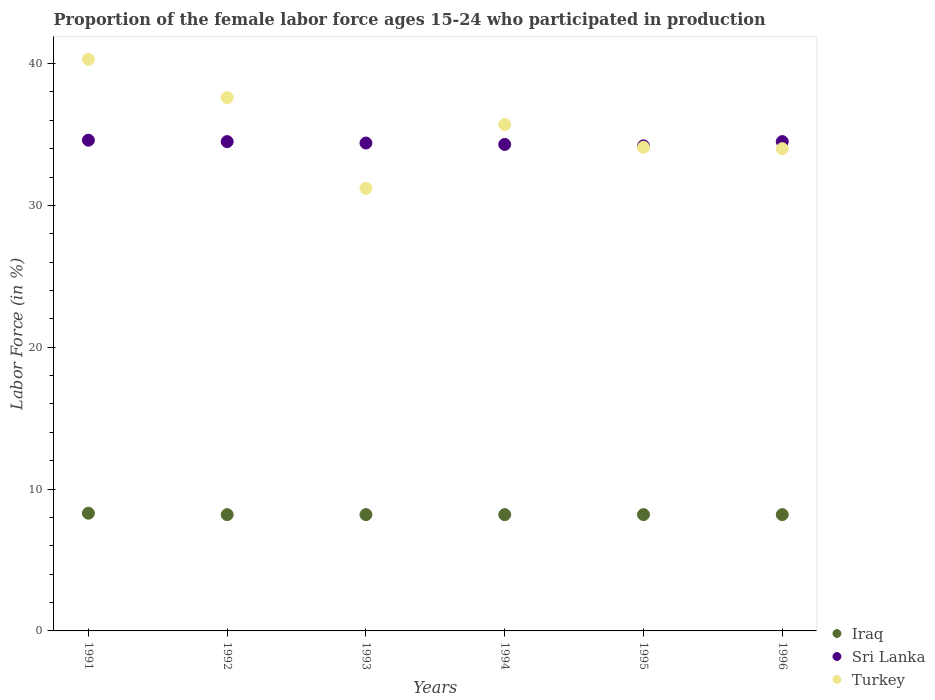How many different coloured dotlines are there?
Your answer should be very brief. 3. Is the number of dotlines equal to the number of legend labels?
Your response must be concise. Yes. What is the proportion of the female labor force who participated in production in Turkey in 1995?
Offer a terse response. 34.1. Across all years, what is the maximum proportion of the female labor force who participated in production in Sri Lanka?
Offer a very short reply. 34.6. Across all years, what is the minimum proportion of the female labor force who participated in production in Iraq?
Keep it short and to the point. 8.2. In which year was the proportion of the female labor force who participated in production in Sri Lanka maximum?
Give a very brief answer. 1991. What is the total proportion of the female labor force who participated in production in Sri Lanka in the graph?
Give a very brief answer. 206.5. What is the difference between the proportion of the female labor force who participated in production in Turkey in 1991 and that in 1995?
Offer a terse response. 6.2. What is the difference between the proportion of the female labor force who participated in production in Turkey in 1993 and the proportion of the female labor force who participated in production in Iraq in 1994?
Provide a short and direct response. 23. What is the average proportion of the female labor force who participated in production in Sri Lanka per year?
Your answer should be very brief. 34.42. In the year 1994, what is the difference between the proportion of the female labor force who participated in production in Turkey and proportion of the female labor force who participated in production in Sri Lanka?
Offer a terse response. 1.4. In how many years, is the proportion of the female labor force who participated in production in Iraq greater than 8 %?
Provide a short and direct response. 6. What is the ratio of the proportion of the female labor force who participated in production in Iraq in 1991 to that in 1994?
Provide a succinct answer. 1.01. What is the difference between the highest and the second highest proportion of the female labor force who participated in production in Turkey?
Your response must be concise. 2.7. What is the difference between the highest and the lowest proportion of the female labor force who participated in production in Sri Lanka?
Your answer should be very brief. 0.4. Is the sum of the proportion of the female labor force who participated in production in Sri Lanka in 1991 and 1996 greater than the maximum proportion of the female labor force who participated in production in Turkey across all years?
Make the answer very short. Yes. What is the title of the graph?
Provide a succinct answer. Proportion of the female labor force ages 15-24 who participated in production. Does "American Samoa" appear as one of the legend labels in the graph?
Offer a very short reply. No. What is the label or title of the X-axis?
Ensure brevity in your answer.  Years. What is the Labor Force (in %) in Iraq in 1991?
Provide a succinct answer. 8.3. What is the Labor Force (in %) of Sri Lanka in 1991?
Offer a terse response. 34.6. What is the Labor Force (in %) of Turkey in 1991?
Make the answer very short. 40.3. What is the Labor Force (in %) of Iraq in 1992?
Ensure brevity in your answer.  8.2. What is the Labor Force (in %) of Sri Lanka in 1992?
Offer a terse response. 34.5. What is the Labor Force (in %) in Turkey in 1992?
Your response must be concise. 37.6. What is the Labor Force (in %) of Iraq in 1993?
Provide a succinct answer. 8.2. What is the Labor Force (in %) of Sri Lanka in 1993?
Make the answer very short. 34.4. What is the Labor Force (in %) in Turkey in 1993?
Your response must be concise. 31.2. What is the Labor Force (in %) of Iraq in 1994?
Offer a terse response. 8.2. What is the Labor Force (in %) of Sri Lanka in 1994?
Your answer should be compact. 34.3. What is the Labor Force (in %) of Turkey in 1994?
Ensure brevity in your answer.  35.7. What is the Labor Force (in %) in Iraq in 1995?
Provide a succinct answer. 8.2. What is the Labor Force (in %) of Sri Lanka in 1995?
Ensure brevity in your answer.  34.2. What is the Labor Force (in %) of Turkey in 1995?
Provide a short and direct response. 34.1. What is the Labor Force (in %) of Iraq in 1996?
Give a very brief answer. 8.2. What is the Labor Force (in %) in Sri Lanka in 1996?
Offer a very short reply. 34.5. What is the Labor Force (in %) in Turkey in 1996?
Provide a succinct answer. 34. Across all years, what is the maximum Labor Force (in %) in Iraq?
Provide a short and direct response. 8.3. Across all years, what is the maximum Labor Force (in %) in Sri Lanka?
Your answer should be very brief. 34.6. Across all years, what is the maximum Labor Force (in %) of Turkey?
Your answer should be compact. 40.3. Across all years, what is the minimum Labor Force (in %) of Iraq?
Ensure brevity in your answer.  8.2. Across all years, what is the minimum Labor Force (in %) of Sri Lanka?
Provide a short and direct response. 34.2. Across all years, what is the minimum Labor Force (in %) of Turkey?
Your answer should be compact. 31.2. What is the total Labor Force (in %) in Iraq in the graph?
Ensure brevity in your answer.  49.3. What is the total Labor Force (in %) in Sri Lanka in the graph?
Make the answer very short. 206.5. What is the total Labor Force (in %) in Turkey in the graph?
Make the answer very short. 212.9. What is the difference between the Labor Force (in %) in Sri Lanka in 1991 and that in 1992?
Your answer should be compact. 0.1. What is the difference between the Labor Force (in %) of Turkey in 1991 and that in 1992?
Give a very brief answer. 2.7. What is the difference between the Labor Force (in %) of Iraq in 1991 and that in 1993?
Offer a terse response. 0.1. What is the difference between the Labor Force (in %) of Sri Lanka in 1991 and that in 1993?
Your answer should be compact. 0.2. What is the difference between the Labor Force (in %) in Turkey in 1991 and that in 1993?
Offer a terse response. 9.1. What is the difference between the Labor Force (in %) in Sri Lanka in 1991 and that in 1994?
Your response must be concise. 0.3. What is the difference between the Labor Force (in %) of Iraq in 1991 and that in 1995?
Your response must be concise. 0.1. What is the difference between the Labor Force (in %) in Turkey in 1991 and that in 1995?
Offer a very short reply. 6.2. What is the difference between the Labor Force (in %) in Sri Lanka in 1991 and that in 1996?
Offer a very short reply. 0.1. What is the difference between the Labor Force (in %) of Turkey in 1991 and that in 1996?
Your response must be concise. 6.3. What is the difference between the Labor Force (in %) of Sri Lanka in 1992 and that in 1993?
Your response must be concise. 0.1. What is the difference between the Labor Force (in %) of Turkey in 1992 and that in 1993?
Offer a terse response. 6.4. What is the difference between the Labor Force (in %) of Iraq in 1992 and that in 1996?
Your answer should be compact. 0. What is the difference between the Labor Force (in %) in Sri Lanka in 1992 and that in 1996?
Offer a very short reply. 0. What is the difference between the Labor Force (in %) of Turkey in 1992 and that in 1996?
Your answer should be very brief. 3.6. What is the difference between the Labor Force (in %) of Sri Lanka in 1993 and that in 1995?
Provide a succinct answer. 0.2. What is the difference between the Labor Force (in %) of Turkey in 1993 and that in 1995?
Provide a short and direct response. -2.9. What is the difference between the Labor Force (in %) in Sri Lanka in 1993 and that in 1996?
Provide a succinct answer. -0.1. What is the difference between the Labor Force (in %) in Iraq in 1994 and that in 1996?
Ensure brevity in your answer.  0. What is the difference between the Labor Force (in %) of Sri Lanka in 1994 and that in 1996?
Keep it short and to the point. -0.2. What is the difference between the Labor Force (in %) of Iraq in 1995 and that in 1996?
Provide a short and direct response. 0. What is the difference between the Labor Force (in %) of Turkey in 1995 and that in 1996?
Ensure brevity in your answer.  0.1. What is the difference between the Labor Force (in %) of Iraq in 1991 and the Labor Force (in %) of Sri Lanka in 1992?
Make the answer very short. -26.2. What is the difference between the Labor Force (in %) in Iraq in 1991 and the Labor Force (in %) in Turkey in 1992?
Provide a short and direct response. -29.3. What is the difference between the Labor Force (in %) in Iraq in 1991 and the Labor Force (in %) in Sri Lanka in 1993?
Ensure brevity in your answer.  -26.1. What is the difference between the Labor Force (in %) in Iraq in 1991 and the Labor Force (in %) in Turkey in 1993?
Your answer should be very brief. -22.9. What is the difference between the Labor Force (in %) in Sri Lanka in 1991 and the Labor Force (in %) in Turkey in 1993?
Your response must be concise. 3.4. What is the difference between the Labor Force (in %) in Iraq in 1991 and the Labor Force (in %) in Turkey in 1994?
Offer a very short reply. -27.4. What is the difference between the Labor Force (in %) of Sri Lanka in 1991 and the Labor Force (in %) of Turkey in 1994?
Provide a short and direct response. -1.1. What is the difference between the Labor Force (in %) in Iraq in 1991 and the Labor Force (in %) in Sri Lanka in 1995?
Keep it short and to the point. -25.9. What is the difference between the Labor Force (in %) of Iraq in 1991 and the Labor Force (in %) of Turkey in 1995?
Ensure brevity in your answer.  -25.8. What is the difference between the Labor Force (in %) in Sri Lanka in 1991 and the Labor Force (in %) in Turkey in 1995?
Provide a short and direct response. 0.5. What is the difference between the Labor Force (in %) in Iraq in 1991 and the Labor Force (in %) in Sri Lanka in 1996?
Your answer should be very brief. -26.2. What is the difference between the Labor Force (in %) in Iraq in 1991 and the Labor Force (in %) in Turkey in 1996?
Your answer should be very brief. -25.7. What is the difference between the Labor Force (in %) in Sri Lanka in 1991 and the Labor Force (in %) in Turkey in 1996?
Your response must be concise. 0.6. What is the difference between the Labor Force (in %) of Iraq in 1992 and the Labor Force (in %) of Sri Lanka in 1993?
Provide a succinct answer. -26.2. What is the difference between the Labor Force (in %) of Iraq in 1992 and the Labor Force (in %) of Sri Lanka in 1994?
Offer a terse response. -26.1. What is the difference between the Labor Force (in %) of Iraq in 1992 and the Labor Force (in %) of Turkey in 1994?
Keep it short and to the point. -27.5. What is the difference between the Labor Force (in %) in Sri Lanka in 1992 and the Labor Force (in %) in Turkey in 1994?
Offer a terse response. -1.2. What is the difference between the Labor Force (in %) in Iraq in 1992 and the Labor Force (in %) in Turkey in 1995?
Offer a very short reply. -25.9. What is the difference between the Labor Force (in %) in Iraq in 1992 and the Labor Force (in %) in Sri Lanka in 1996?
Ensure brevity in your answer.  -26.3. What is the difference between the Labor Force (in %) in Iraq in 1992 and the Labor Force (in %) in Turkey in 1996?
Provide a short and direct response. -25.8. What is the difference between the Labor Force (in %) in Sri Lanka in 1992 and the Labor Force (in %) in Turkey in 1996?
Your answer should be very brief. 0.5. What is the difference between the Labor Force (in %) in Iraq in 1993 and the Labor Force (in %) in Sri Lanka in 1994?
Ensure brevity in your answer.  -26.1. What is the difference between the Labor Force (in %) in Iraq in 1993 and the Labor Force (in %) in Turkey in 1994?
Ensure brevity in your answer.  -27.5. What is the difference between the Labor Force (in %) of Iraq in 1993 and the Labor Force (in %) of Turkey in 1995?
Your answer should be compact. -25.9. What is the difference between the Labor Force (in %) of Iraq in 1993 and the Labor Force (in %) of Sri Lanka in 1996?
Ensure brevity in your answer.  -26.3. What is the difference between the Labor Force (in %) in Iraq in 1993 and the Labor Force (in %) in Turkey in 1996?
Your response must be concise. -25.8. What is the difference between the Labor Force (in %) of Iraq in 1994 and the Labor Force (in %) of Sri Lanka in 1995?
Your answer should be compact. -26. What is the difference between the Labor Force (in %) in Iraq in 1994 and the Labor Force (in %) in Turkey in 1995?
Ensure brevity in your answer.  -25.9. What is the difference between the Labor Force (in %) of Iraq in 1994 and the Labor Force (in %) of Sri Lanka in 1996?
Keep it short and to the point. -26.3. What is the difference between the Labor Force (in %) of Iraq in 1994 and the Labor Force (in %) of Turkey in 1996?
Give a very brief answer. -25.8. What is the difference between the Labor Force (in %) of Iraq in 1995 and the Labor Force (in %) of Sri Lanka in 1996?
Your response must be concise. -26.3. What is the difference between the Labor Force (in %) in Iraq in 1995 and the Labor Force (in %) in Turkey in 1996?
Offer a very short reply. -25.8. What is the average Labor Force (in %) in Iraq per year?
Make the answer very short. 8.22. What is the average Labor Force (in %) in Sri Lanka per year?
Provide a succinct answer. 34.42. What is the average Labor Force (in %) in Turkey per year?
Your response must be concise. 35.48. In the year 1991, what is the difference between the Labor Force (in %) in Iraq and Labor Force (in %) in Sri Lanka?
Make the answer very short. -26.3. In the year 1991, what is the difference between the Labor Force (in %) of Iraq and Labor Force (in %) of Turkey?
Your answer should be very brief. -32. In the year 1991, what is the difference between the Labor Force (in %) in Sri Lanka and Labor Force (in %) in Turkey?
Provide a succinct answer. -5.7. In the year 1992, what is the difference between the Labor Force (in %) in Iraq and Labor Force (in %) in Sri Lanka?
Offer a very short reply. -26.3. In the year 1992, what is the difference between the Labor Force (in %) of Iraq and Labor Force (in %) of Turkey?
Provide a succinct answer. -29.4. In the year 1993, what is the difference between the Labor Force (in %) of Iraq and Labor Force (in %) of Sri Lanka?
Your response must be concise. -26.2. In the year 1993, what is the difference between the Labor Force (in %) of Iraq and Labor Force (in %) of Turkey?
Your response must be concise. -23. In the year 1993, what is the difference between the Labor Force (in %) of Sri Lanka and Labor Force (in %) of Turkey?
Keep it short and to the point. 3.2. In the year 1994, what is the difference between the Labor Force (in %) of Iraq and Labor Force (in %) of Sri Lanka?
Offer a terse response. -26.1. In the year 1994, what is the difference between the Labor Force (in %) in Iraq and Labor Force (in %) in Turkey?
Make the answer very short. -27.5. In the year 1995, what is the difference between the Labor Force (in %) in Iraq and Labor Force (in %) in Sri Lanka?
Provide a short and direct response. -26. In the year 1995, what is the difference between the Labor Force (in %) of Iraq and Labor Force (in %) of Turkey?
Give a very brief answer. -25.9. In the year 1995, what is the difference between the Labor Force (in %) in Sri Lanka and Labor Force (in %) in Turkey?
Give a very brief answer. 0.1. In the year 1996, what is the difference between the Labor Force (in %) of Iraq and Labor Force (in %) of Sri Lanka?
Your answer should be compact. -26.3. In the year 1996, what is the difference between the Labor Force (in %) in Iraq and Labor Force (in %) in Turkey?
Make the answer very short. -25.8. In the year 1996, what is the difference between the Labor Force (in %) in Sri Lanka and Labor Force (in %) in Turkey?
Your response must be concise. 0.5. What is the ratio of the Labor Force (in %) in Iraq in 1991 to that in 1992?
Your answer should be compact. 1.01. What is the ratio of the Labor Force (in %) of Sri Lanka in 1991 to that in 1992?
Your answer should be compact. 1. What is the ratio of the Labor Force (in %) in Turkey in 1991 to that in 1992?
Offer a terse response. 1.07. What is the ratio of the Labor Force (in %) of Iraq in 1991 to that in 1993?
Keep it short and to the point. 1.01. What is the ratio of the Labor Force (in %) of Sri Lanka in 1991 to that in 1993?
Make the answer very short. 1.01. What is the ratio of the Labor Force (in %) of Turkey in 1991 to that in 1993?
Give a very brief answer. 1.29. What is the ratio of the Labor Force (in %) of Iraq in 1991 to that in 1994?
Offer a terse response. 1.01. What is the ratio of the Labor Force (in %) in Sri Lanka in 1991 to that in 1994?
Provide a succinct answer. 1.01. What is the ratio of the Labor Force (in %) of Turkey in 1991 to that in 1994?
Ensure brevity in your answer.  1.13. What is the ratio of the Labor Force (in %) of Iraq in 1991 to that in 1995?
Offer a terse response. 1.01. What is the ratio of the Labor Force (in %) in Sri Lanka in 1991 to that in 1995?
Make the answer very short. 1.01. What is the ratio of the Labor Force (in %) in Turkey in 1991 to that in 1995?
Ensure brevity in your answer.  1.18. What is the ratio of the Labor Force (in %) of Iraq in 1991 to that in 1996?
Your answer should be compact. 1.01. What is the ratio of the Labor Force (in %) of Sri Lanka in 1991 to that in 1996?
Your answer should be compact. 1. What is the ratio of the Labor Force (in %) in Turkey in 1991 to that in 1996?
Provide a short and direct response. 1.19. What is the ratio of the Labor Force (in %) in Iraq in 1992 to that in 1993?
Keep it short and to the point. 1. What is the ratio of the Labor Force (in %) in Turkey in 1992 to that in 1993?
Your answer should be very brief. 1.21. What is the ratio of the Labor Force (in %) of Turkey in 1992 to that in 1994?
Your response must be concise. 1.05. What is the ratio of the Labor Force (in %) in Sri Lanka in 1992 to that in 1995?
Provide a succinct answer. 1.01. What is the ratio of the Labor Force (in %) in Turkey in 1992 to that in 1995?
Your response must be concise. 1.1. What is the ratio of the Labor Force (in %) of Turkey in 1992 to that in 1996?
Provide a short and direct response. 1.11. What is the ratio of the Labor Force (in %) of Sri Lanka in 1993 to that in 1994?
Ensure brevity in your answer.  1. What is the ratio of the Labor Force (in %) of Turkey in 1993 to that in 1994?
Offer a terse response. 0.87. What is the ratio of the Labor Force (in %) of Turkey in 1993 to that in 1995?
Your answer should be very brief. 0.92. What is the ratio of the Labor Force (in %) of Iraq in 1993 to that in 1996?
Provide a succinct answer. 1. What is the ratio of the Labor Force (in %) in Sri Lanka in 1993 to that in 1996?
Offer a very short reply. 1. What is the ratio of the Labor Force (in %) of Turkey in 1993 to that in 1996?
Provide a short and direct response. 0.92. What is the ratio of the Labor Force (in %) of Iraq in 1994 to that in 1995?
Your response must be concise. 1. What is the ratio of the Labor Force (in %) in Sri Lanka in 1994 to that in 1995?
Provide a succinct answer. 1. What is the ratio of the Labor Force (in %) in Turkey in 1994 to that in 1995?
Make the answer very short. 1.05. What is the ratio of the Labor Force (in %) in Sri Lanka in 1994 to that in 1996?
Provide a succinct answer. 0.99. What is the ratio of the Labor Force (in %) in Turkey in 1994 to that in 1996?
Your response must be concise. 1.05. What is the ratio of the Labor Force (in %) of Iraq in 1995 to that in 1996?
Offer a very short reply. 1. What is the ratio of the Labor Force (in %) in Sri Lanka in 1995 to that in 1996?
Your answer should be very brief. 0.99. What is the difference between the highest and the second highest Labor Force (in %) of Iraq?
Offer a very short reply. 0.1. What is the difference between the highest and the second highest Labor Force (in %) in Turkey?
Provide a succinct answer. 2.7. What is the difference between the highest and the lowest Labor Force (in %) of Sri Lanka?
Ensure brevity in your answer.  0.4. What is the difference between the highest and the lowest Labor Force (in %) in Turkey?
Ensure brevity in your answer.  9.1. 